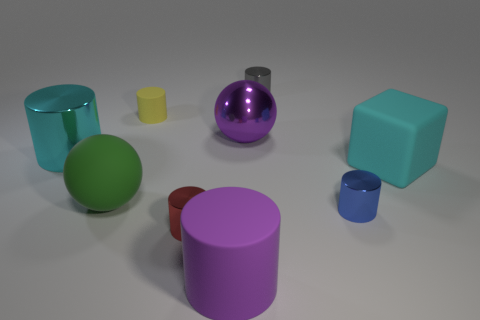Is there anything else that is the same shape as the cyan matte object?
Ensure brevity in your answer.  No. What material is the cyan cube that is the same size as the cyan metallic object?
Ensure brevity in your answer.  Rubber. There is a cyan object that is on the right side of the purple object in front of the large cyan object behind the big cyan cube; what is it made of?
Make the answer very short. Rubber. There is a green object behind the blue object; does it have the same size as the big matte cube?
Your response must be concise. Yes. Is the number of purple cylinders greater than the number of blue matte cubes?
Offer a terse response. Yes. How many small objects are blue cylinders or cyan matte objects?
Offer a very short reply. 1. How many other things are the same color as the matte ball?
Give a very brief answer. 0. How many gray cylinders have the same material as the large block?
Offer a terse response. 0. Does the big metal object that is on the right side of the cyan metallic cylinder have the same color as the big matte cylinder?
Provide a succinct answer. Yes. What number of gray objects are tiny metallic balls or matte cubes?
Offer a very short reply. 0. 